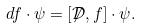Convert formula to latex. <formula><loc_0><loc_0><loc_500><loc_500>d f \cdot \psi = [ { \not } \mathcal { D } , f ] \cdot \psi .</formula> 